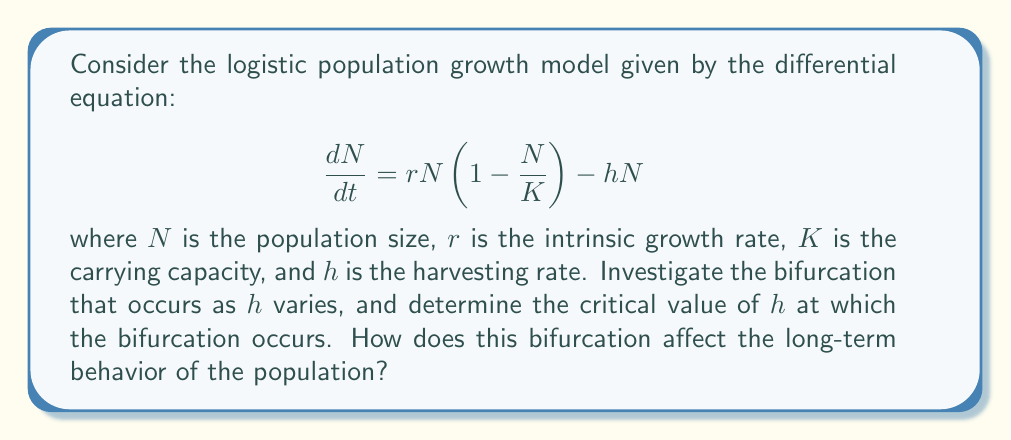What is the answer to this math problem? Let's approach this step-by-step:

1) First, we need to find the equilibrium points of the system. Set $\frac{dN}{dt} = 0$:

   $$rN\left(1 - \frac{N}{K}\right) - hN = 0$$

2) Factor out $N$:

   $$N\left[r\left(1 - \frac{N}{K}\right) - h\right] = 0$$

3) Solve for $N$:
   
   $N = 0$ or $r\left(1 - \frac{N}{K}\right) - h = 0$

4) From the second equation:

   $$N = K\left(1 - \frac{h}{r}\right)$$

5) The equilibrium points are:

   $$N_1 = 0 \text{ and } N_2 = K\left(1 - \frac{h}{r}\right)$$

6) $N_2$ is only biologically meaningful when it's positive, i.e., when $h < r$.

7) To determine stability, we calculate the derivative of the right-hand side with respect to $N$:

   $$\frac{d}{dN}\left[rN\left(1 - \frac{N}{K}\right) - hN\right] = r - \frac{2rN}{K} - h$$

8) At $N_1 = 0$, the derivative is $r - h$. This equilibrium is stable when $r - h < 0$, i.e., when $h > r$.

9) At $N_2 = K\left(1 - \frac{h}{r}\right)$, the derivative is $h - r$. This equilibrium is stable when $h - r < 0$, i.e., when $h < r$.

10) The bifurcation occurs when $h = r$. At this point, the two equilibria exchange stability.

11) This is a transcritical bifurcation. When $h < r$, the non-zero equilibrium $N_2$ is stable and the population persists. When $h > r$, the zero equilibrium $N_1$ is stable and the population goes extinct.

[asy]
size(200,200);
import graph;

real f(real x) {return x*(1-x);}
real g(real x) {return 0.5*x;}

draw(graph(f,0,1),blue);
draw(graph(g,0,1),red);

xaxis("h",0,1,Arrow);
yaxis("N",0,1,Arrow);

label("Stable",
Answer: Transcritical bifurcation at $h = r$ 